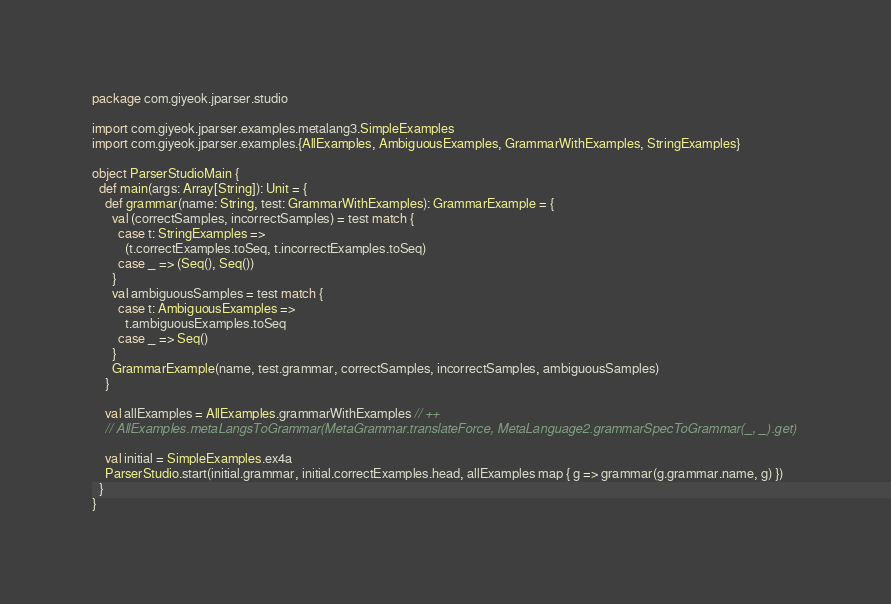Convert code to text. <code><loc_0><loc_0><loc_500><loc_500><_Scala_>package com.giyeok.jparser.studio

import com.giyeok.jparser.examples.metalang3.SimpleExamples
import com.giyeok.jparser.examples.{AllExamples, AmbiguousExamples, GrammarWithExamples, StringExamples}

object ParserStudioMain {
  def main(args: Array[String]): Unit = {
    def grammar(name: String, test: GrammarWithExamples): GrammarExample = {
      val (correctSamples, incorrectSamples) = test match {
        case t: StringExamples =>
          (t.correctExamples.toSeq, t.incorrectExamples.toSeq)
        case _ => (Seq(), Seq())
      }
      val ambiguousSamples = test match {
        case t: AmbiguousExamples =>
          t.ambiguousExamples.toSeq
        case _ => Seq()
      }
      GrammarExample(name, test.grammar, correctSamples, incorrectSamples, ambiguousSamples)
    }

    val allExamples = AllExamples.grammarWithExamples // ++
    // AllExamples.metaLangsToGrammar(MetaGrammar.translateForce, MetaLanguage2.grammarSpecToGrammar(_, _).get)

    val initial = SimpleExamples.ex4a
    ParserStudio.start(initial.grammar, initial.correctExamples.head, allExamples map { g => grammar(g.grammar.name, g) })
  }
}
</code> 